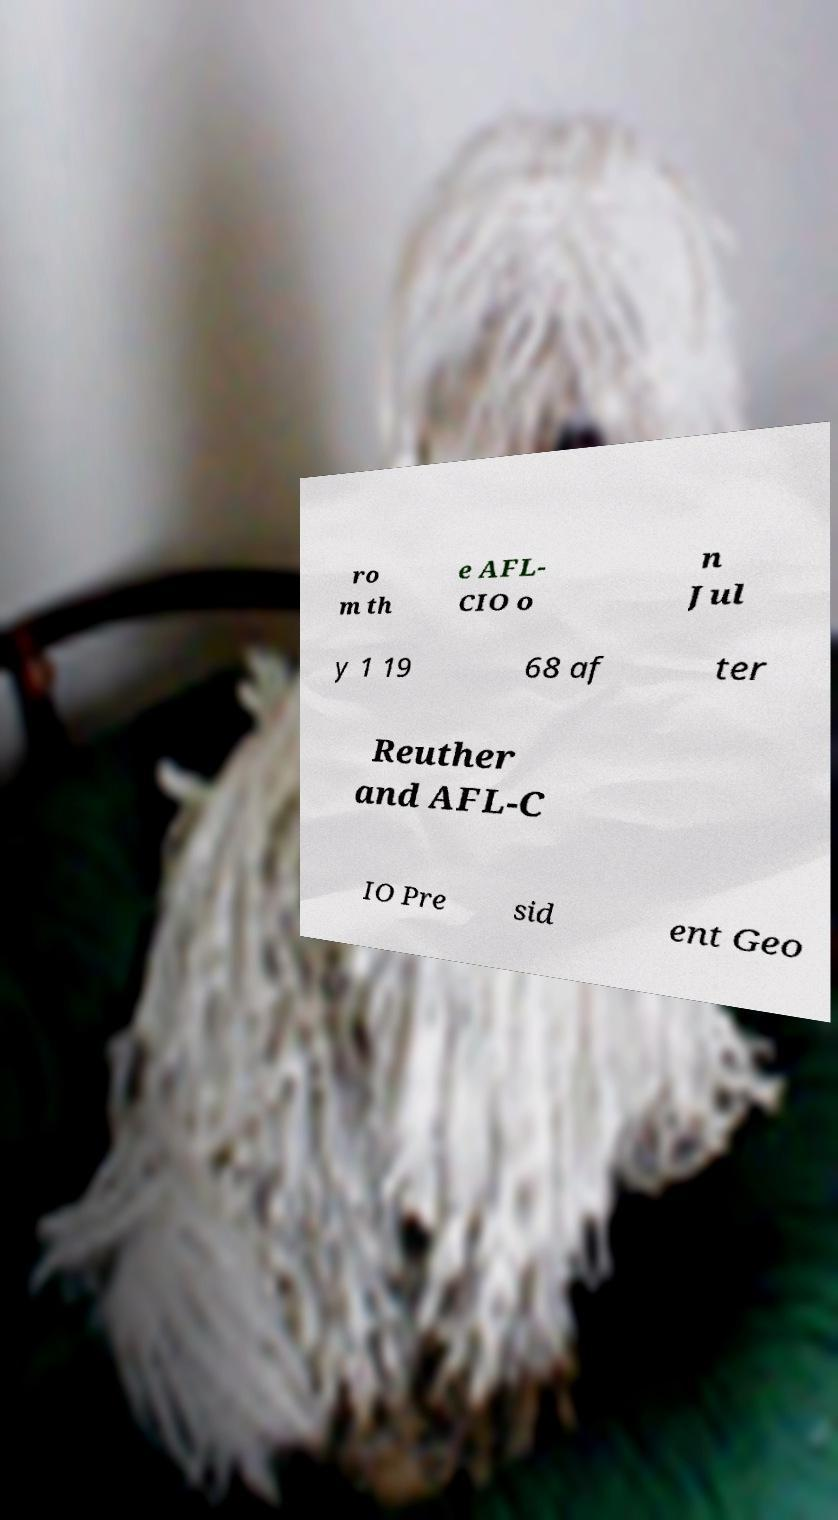Please read and relay the text visible in this image. What does it say? ro m th e AFL- CIO o n Jul y 1 19 68 af ter Reuther and AFL-C IO Pre sid ent Geo 